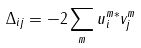Convert formula to latex. <formula><loc_0><loc_0><loc_500><loc_500>\Delta _ { i j } = - 2 \sum _ { m } u ^ { m * } _ { i } v ^ { m } _ { j }</formula> 